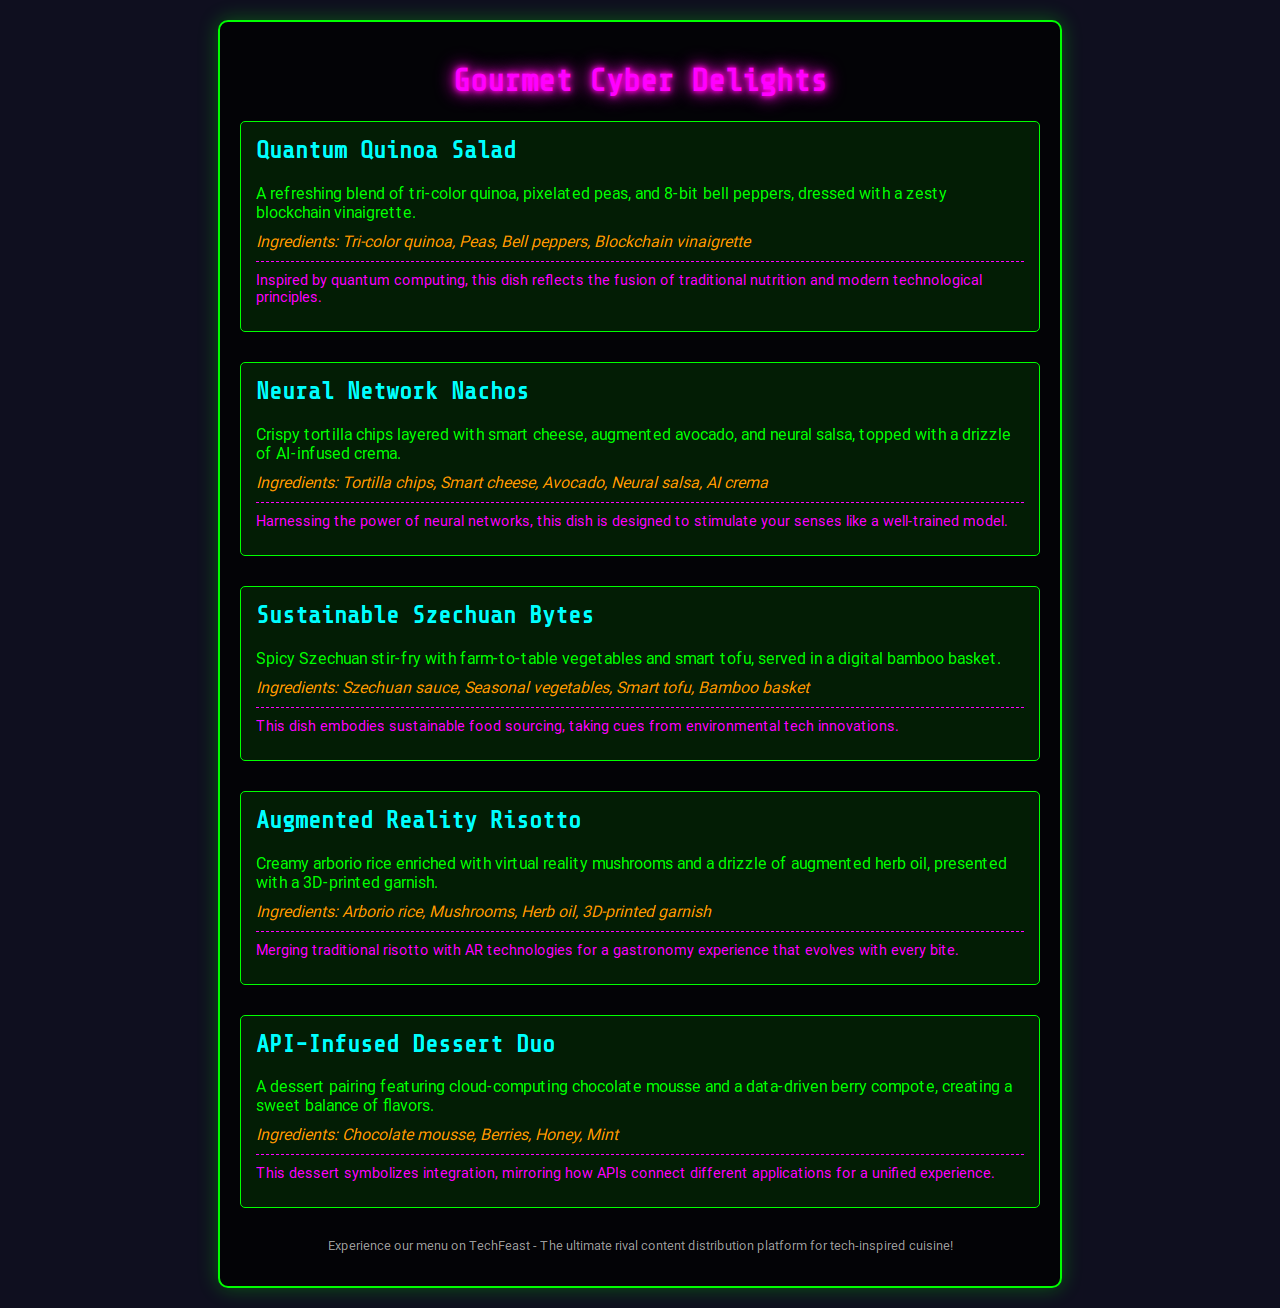what is the name of the first menu item? The first menu item is clearly labeled as "Quantum Quinoa Salad."
Answer: Quantum Quinoa Salad how many main dishes are listed on the menu? The menu lists a total of five main dishes, excluding the dessert.
Answer: 5 which ingredient is used in the Neural Network Nachos? The ingredients of the Neural Network Nachos include smart cheese, which is one of the specified components.
Answer: Smart cheese what type of dessert is featured in the API-Infused Dessert Duo? The dessert pairing specifically includes chocolate mousse as one of its main components.
Answer: Chocolate mousse what does the Augmented Reality Risotto feature as a garnish? The dish mentions a 3D-printed garnish, highlighting the innovative presentation of the meal.
Answer: 3D-printed garnish which dish is inspired by sustainable food sourcing? Sustainable Szechuan Bytes is the dish that embodies sustainable food sourcing.
Answer: Sustainable Szechuan Bytes what is the background color of the menu? The document indicates that the background color is a dark shade, specifically referred to as "rgba(0, 0, 0, 0.8)."
Answer: rgba(0, 0, 0, 0.8) which platform is promoted at the end of the document? The document promotes a platform named TechFeast at its conclusion.
Answer: TechFeast 